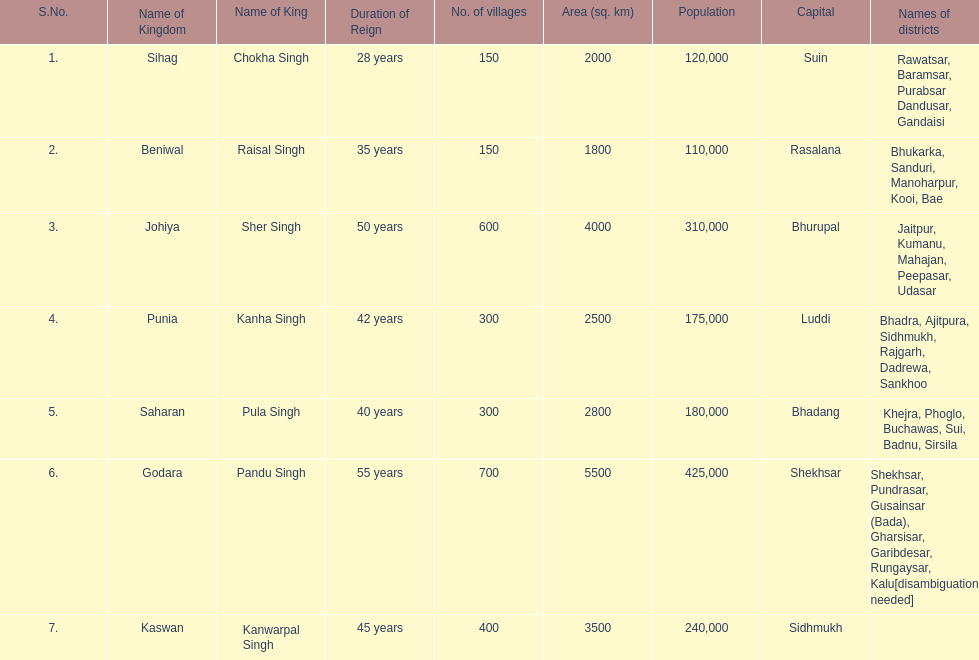What is the count of districts within punia? 6. 